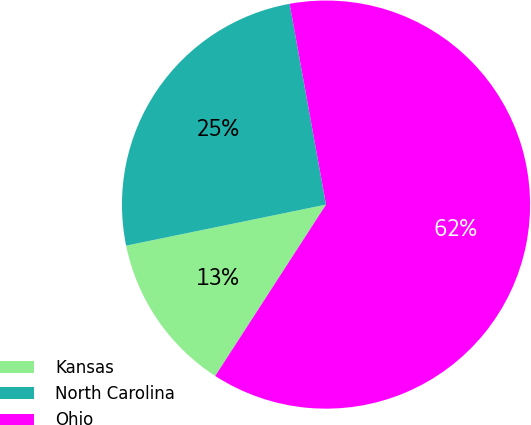<chart> <loc_0><loc_0><loc_500><loc_500><pie_chart><fcel>Kansas<fcel>North Carolina<fcel>Ohio<nl><fcel>12.64%<fcel>25.37%<fcel>61.99%<nl></chart> 